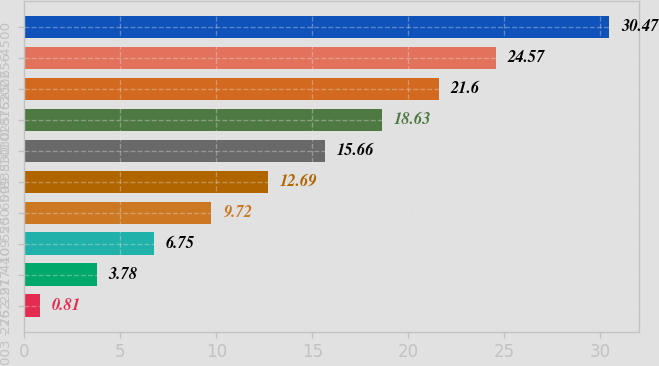<chart> <loc_0><loc_0><loc_500><loc_500><bar_chart><fcel>003 - 262<fcel>275 - 277<fcel>291 - 409<fcel>410 - 500<fcel>525 - 599<fcel>600 - 830<fcel>835 - 1025<fcel>1030 - 1625<fcel>1875 - 2256<fcel>3006 - 4500<nl><fcel>0.81<fcel>3.78<fcel>6.75<fcel>9.72<fcel>12.69<fcel>15.66<fcel>18.63<fcel>21.6<fcel>24.57<fcel>30.47<nl></chart> 